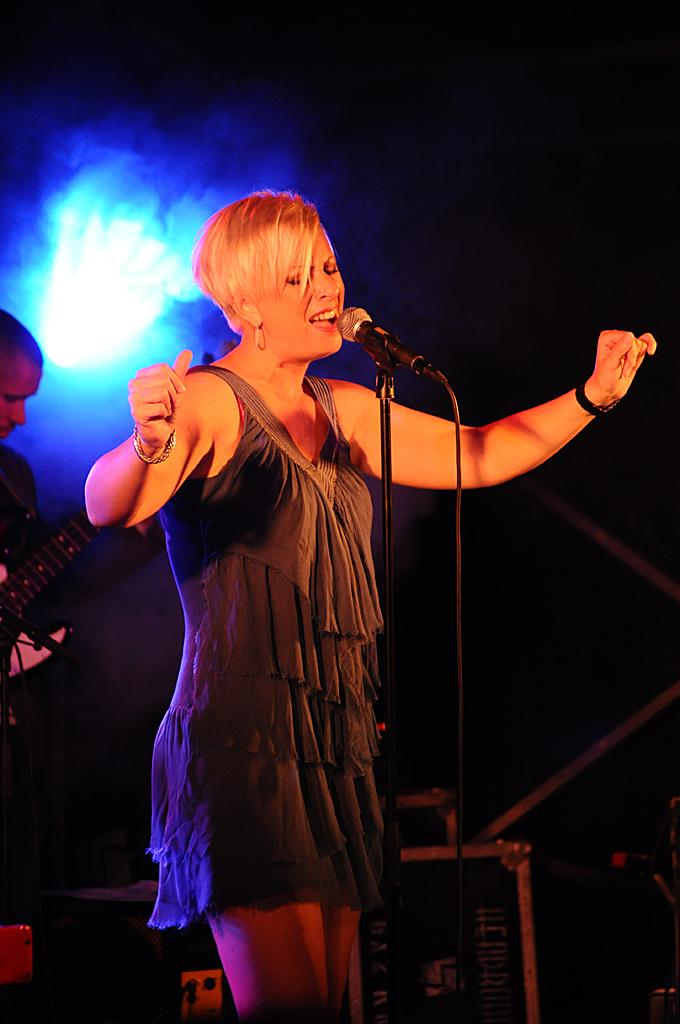What is the woman doing in the image? The woman is standing in the image. What object is present that is typically used for amplifying sound? There is a microphone in the image. What musical instrument is being played in the image? A person is playing a guitar in the image. What can be seen providing illumination in the image? There is a light in the image. How many facts can be seen laughing in the image? There are no facts present in the image, and facts do not have the ability to laugh. What type of thumb is visible on the guitar player's hand in the image? There is no thumb visible on the guitar player's hand in the image. 